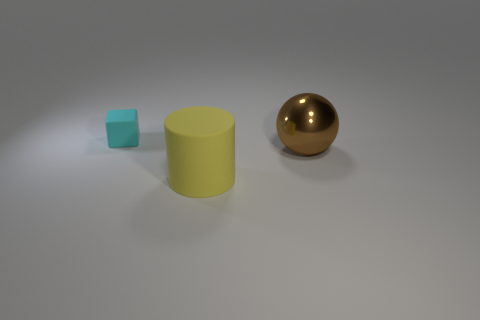Is the shape of the big object to the left of the metal ball the same as  the cyan rubber object?
Your answer should be very brief. No. How many objects are both right of the cylinder and to the left of the big metallic ball?
Your answer should be very brief. 0. What number of other things are there of the same size as the yellow object?
Your response must be concise. 1. Are there the same number of small blocks right of the tiny cyan thing and tiny cyan matte blocks?
Provide a short and direct response. No. There is a thing that is both behind the large yellow thing and left of the sphere; what is its material?
Ensure brevity in your answer.  Rubber. What color is the big ball?
Keep it short and to the point. Brown. What number of other things are there of the same shape as the big yellow matte thing?
Keep it short and to the point. 0. Are there an equal number of cyan cubes to the right of the big yellow thing and matte things behind the small cyan block?
Your answer should be compact. Yes. What is the material of the brown ball?
Provide a short and direct response. Metal. What is the big thing that is behind the large cylinder made of?
Your answer should be compact. Metal. 